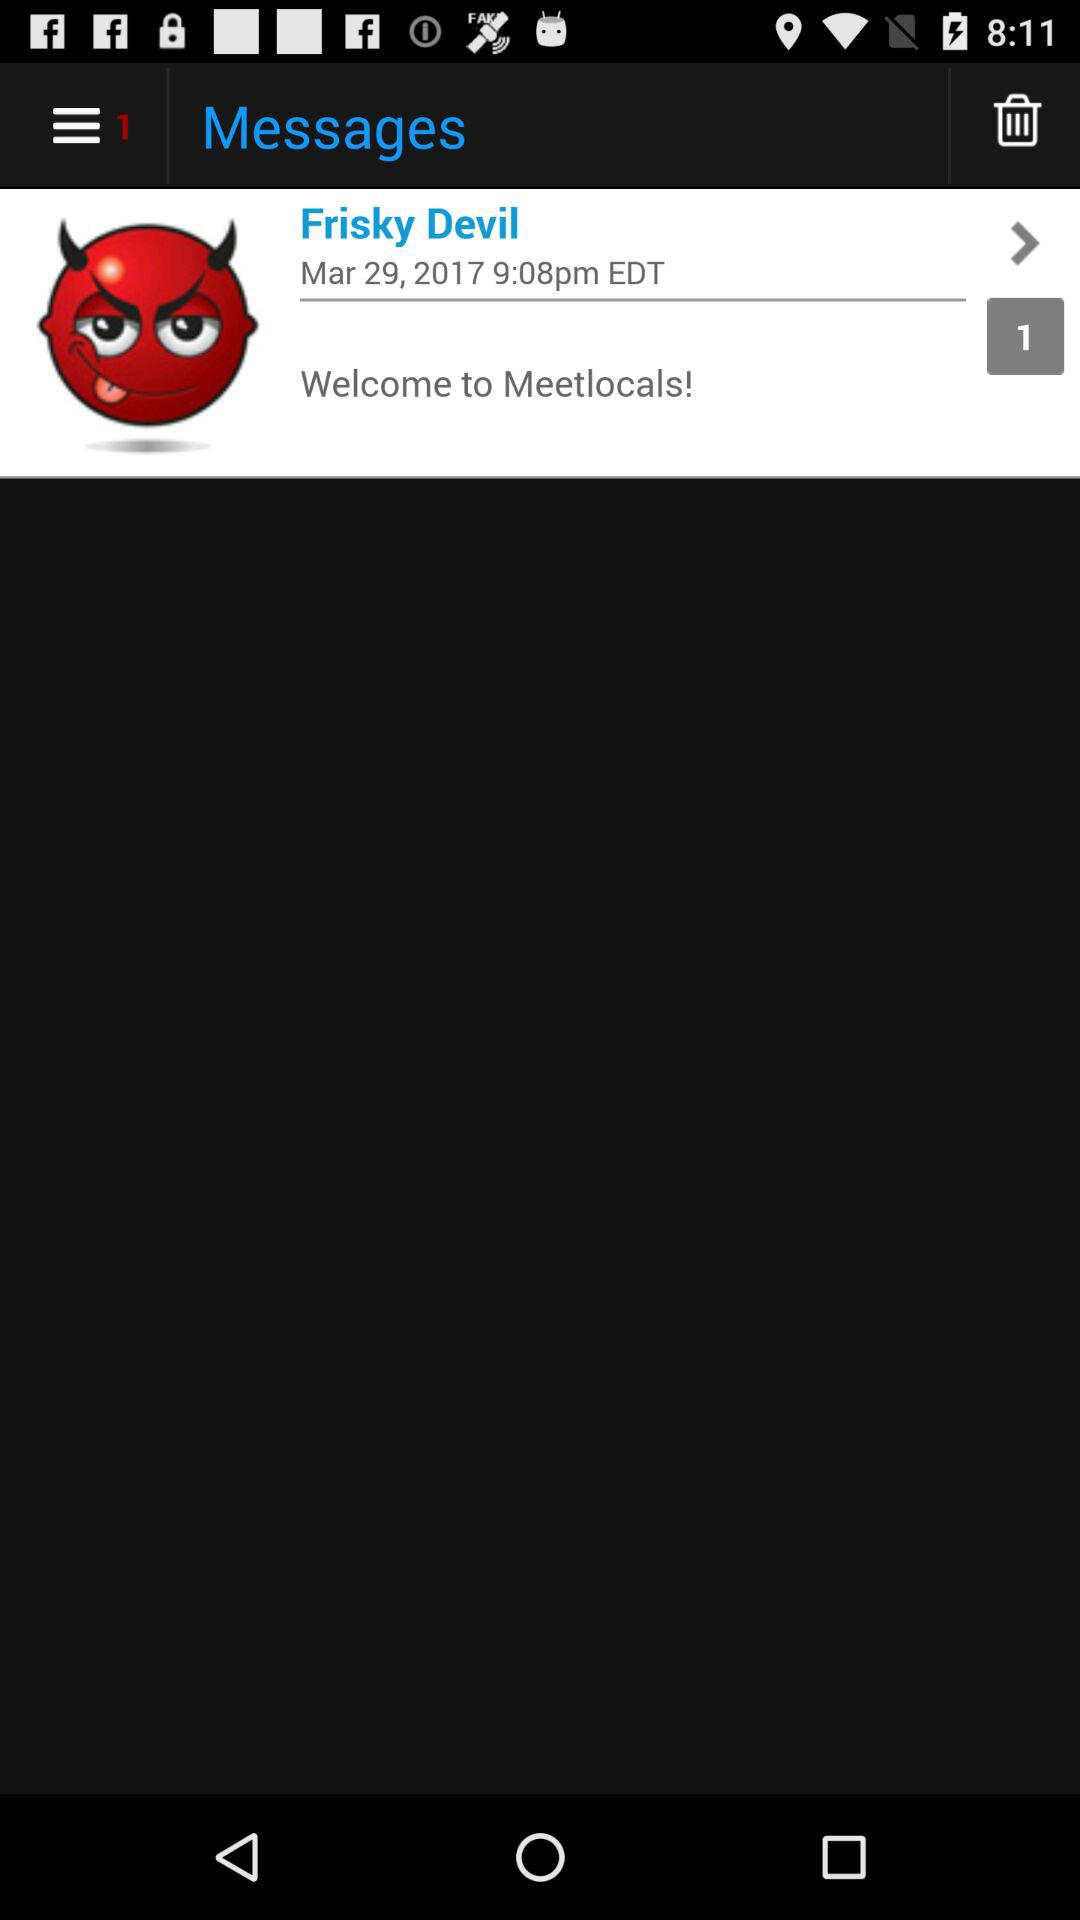At what time was the message received by Frisky Devil? The message was received by Frisky Devil at 9:08 pm EDT. 